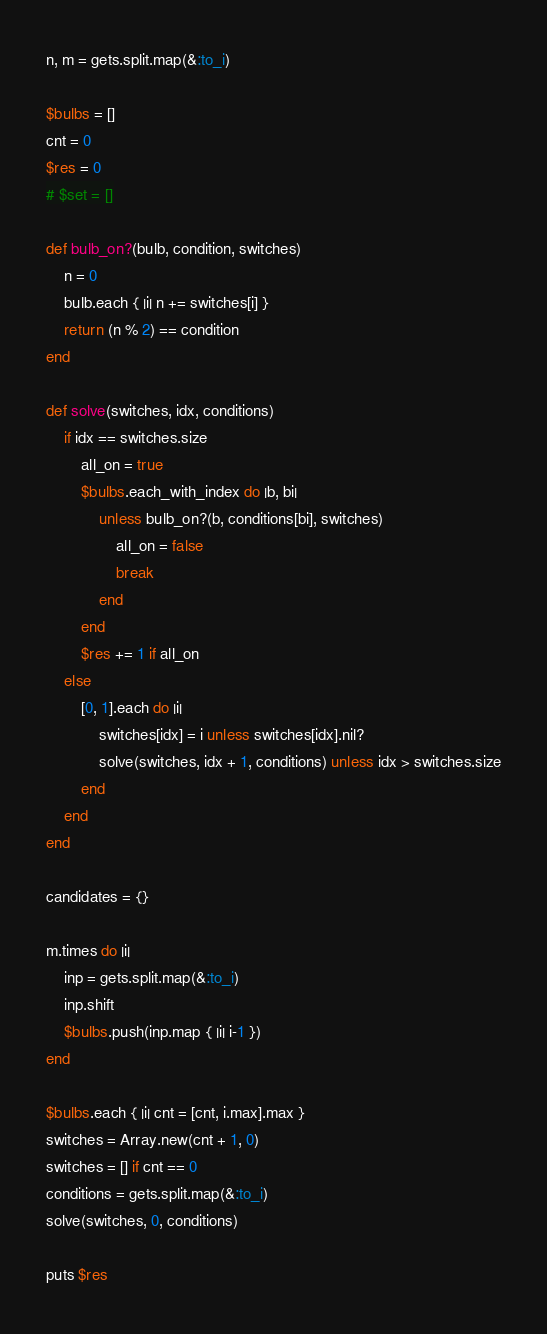Convert code to text. <code><loc_0><loc_0><loc_500><loc_500><_Ruby_>n, m = gets.split.map(&:to_i)

$bulbs = []
cnt = 0
$res = 0
# $set = []

def bulb_on?(bulb, condition, switches)
    n = 0
    bulb.each { |i| n += switches[i] }
    return (n % 2) == condition
end

def solve(switches, idx, conditions)
    if idx == switches.size 
        all_on = true
        $bulbs.each_with_index do |b, bi|
            unless bulb_on?(b, conditions[bi], switches)
                all_on = false
                break
            end
        end
        $res += 1 if all_on
    else 
        [0, 1].each do |i|
            switches[idx] = i unless switches[idx].nil?
            solve(switches, idx + 1, conditions) unless idx > switches.size
        end
    end
end

candidates = {}

m.times do |i|
    inp = gets.split.map(&:to_i)
    inp.shift
    $bulbs.push(inp.map { |i| i-1 })
end

$bulbs.each { |i| cnt = [cnt, i.max].max }
switches = Array.new(cnt + 1, 0)
switches = [] if cnt == 0
conditions = gets.split.map(&:to_i)
solve(switches, 0, conditions)

puts $res</code> 